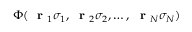<formula> <loc_0><loc_0><loc_500><loc_500>\Phi ( r _ { 1 } \sigma _ { 1 } , r _ { 2 } \sigma _ { 2 } , \dots , r _ { N } \sigma _ { N } )</formula> 